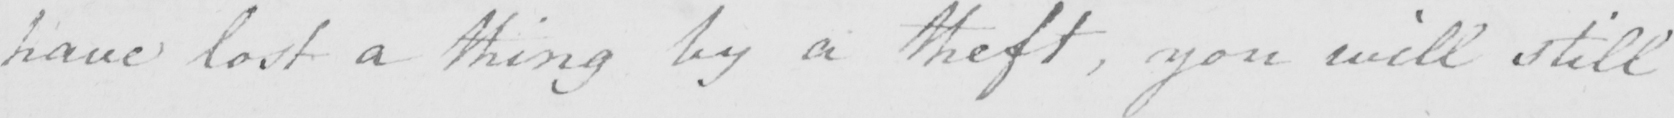Can you read and transcribe this handwriting? have lost a thing by a theft , you will still 